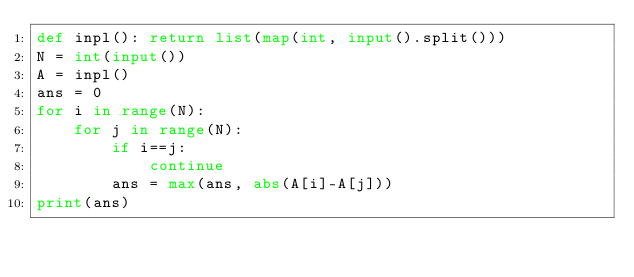<code> <loc_0><loc_0><loc_500><loc_500><_Python_>def inpl(): return list(map(int, input().split()))
N = int(input())
A = inpl()
ans = 0
for i in range(N):
    for j in range(N):
        if i==j:
            continue
        ans = max(ans, abs(A[i]-A[j]))
print(ans)</code> 